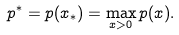<formula> <loc_0><loc_0><loc_500><loc_500>p ^ { * } = p ( x _ { * } ) = \max _ { x > 0 } p ( x ) .</formula> 